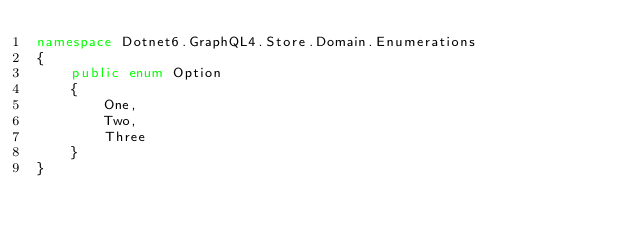<code> <loc_0><loc_0><loc_500><loc_500><_C#_>namespace Dotnet6.GraphQL4.Store.Domain.Enumerations
{
    public enum Option
    {
        One,
        Two,
        Three
    }
}</code> 